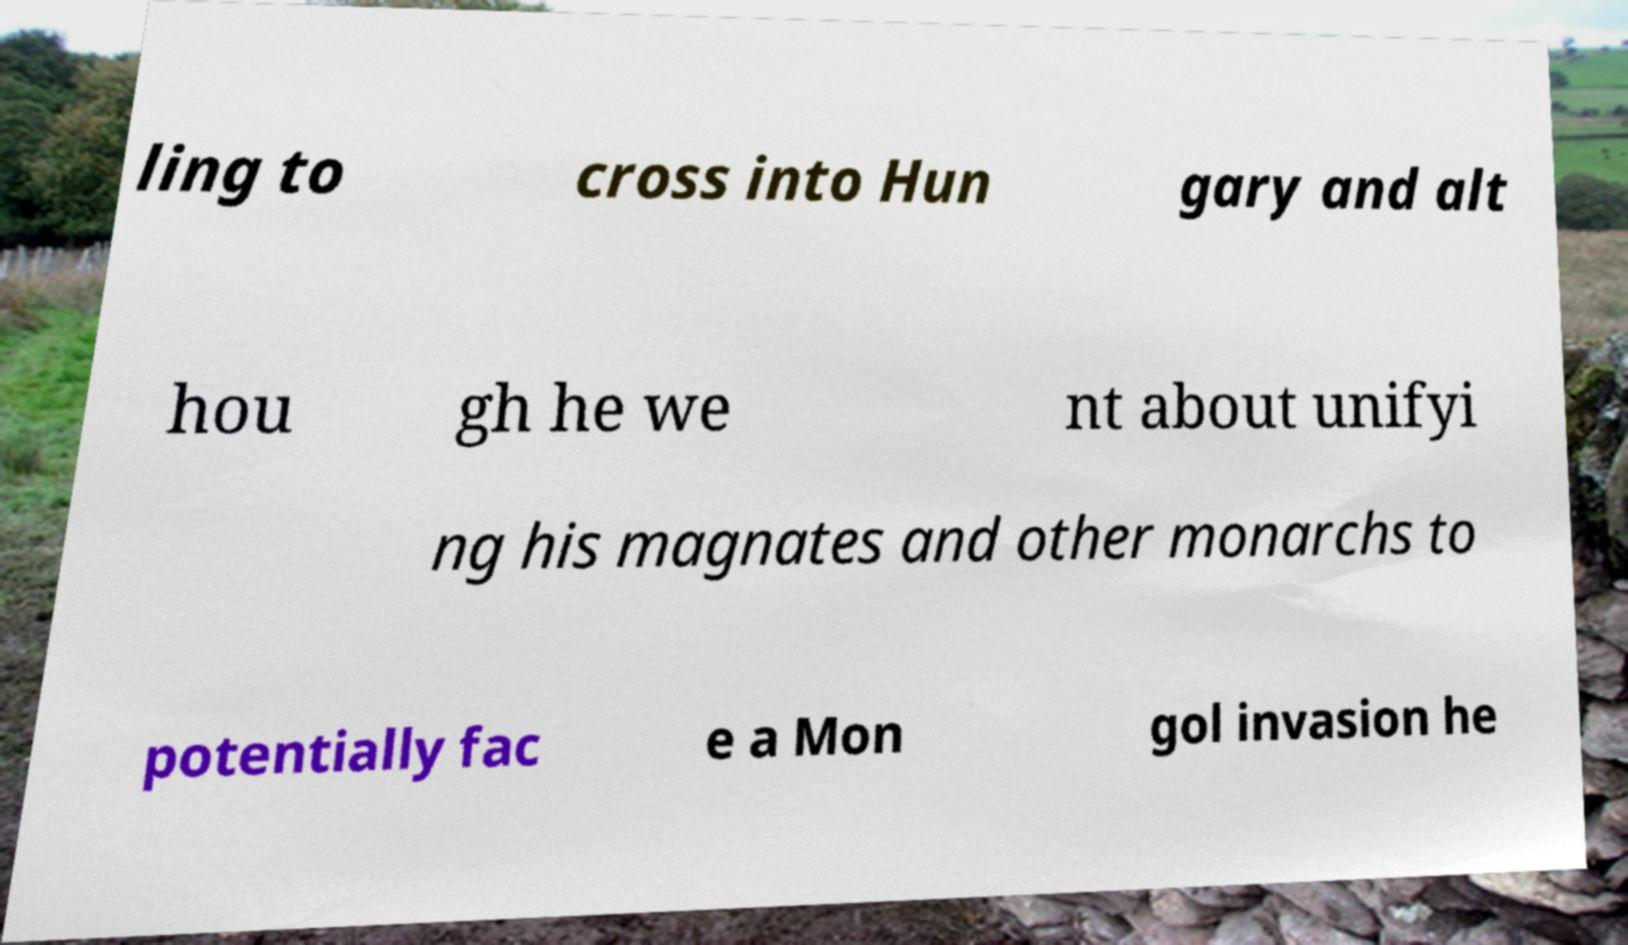There's text embedded in this image that I need extracted. Can you transcribe it verbatim? ling to cross into Hun gary and alt hou gh he we nt about unifyi ng his magnates and other monarchs to potentially fac e a Mon gol invasion he 